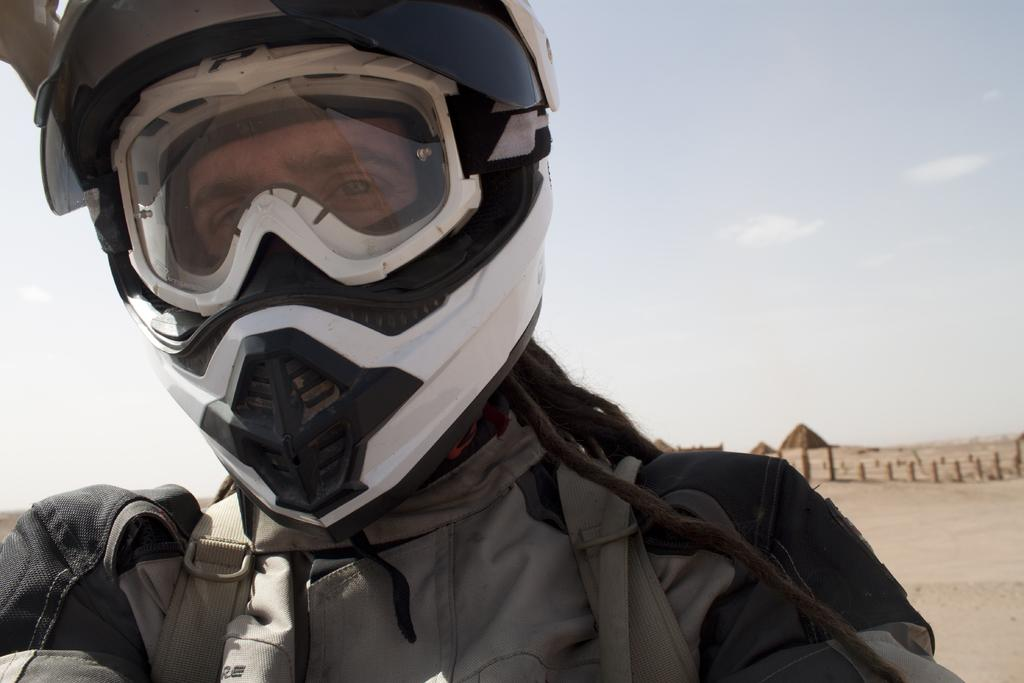Who is the main subject in the image? There is a man in the center of the image. What is the man wearing on his head? The man is wearing a helmet. What can be seen in the background of the image? There are poles and an object that is brown in color in the background. How would you describe the weather based on the image? The sky is cloudy in the image. Can you tell me how many strangers are interacting with the man in the image? There is no stranger present in the image; it only features a man wearing a helmet. What type of nut can be seen growing on the poles in the background? There are no nuts visible on the poles in the background; they are just poles. 